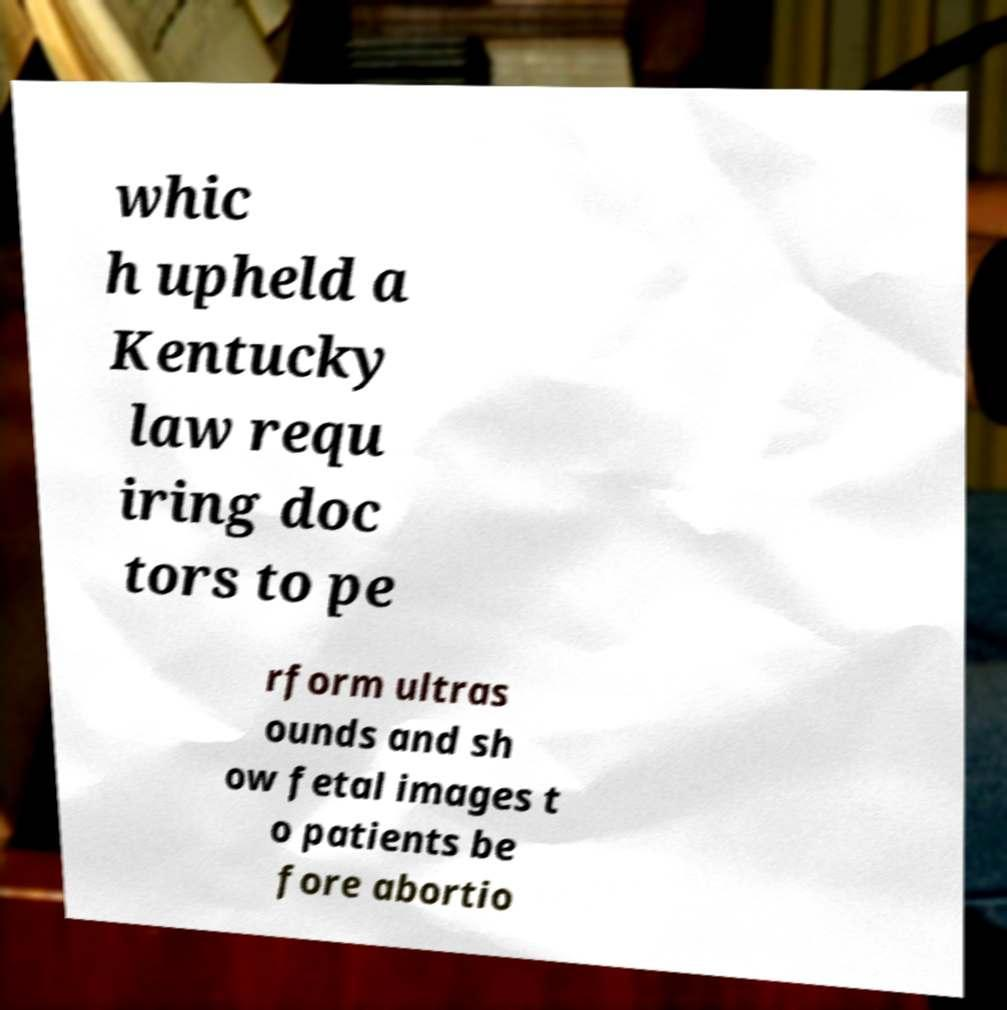Please identify and transcribe the text found in this image. whic h upheld a Kentucky law requ iring doc tors to pe rform ultras ounds and sh ow fetal images t o patients be fore abortio 